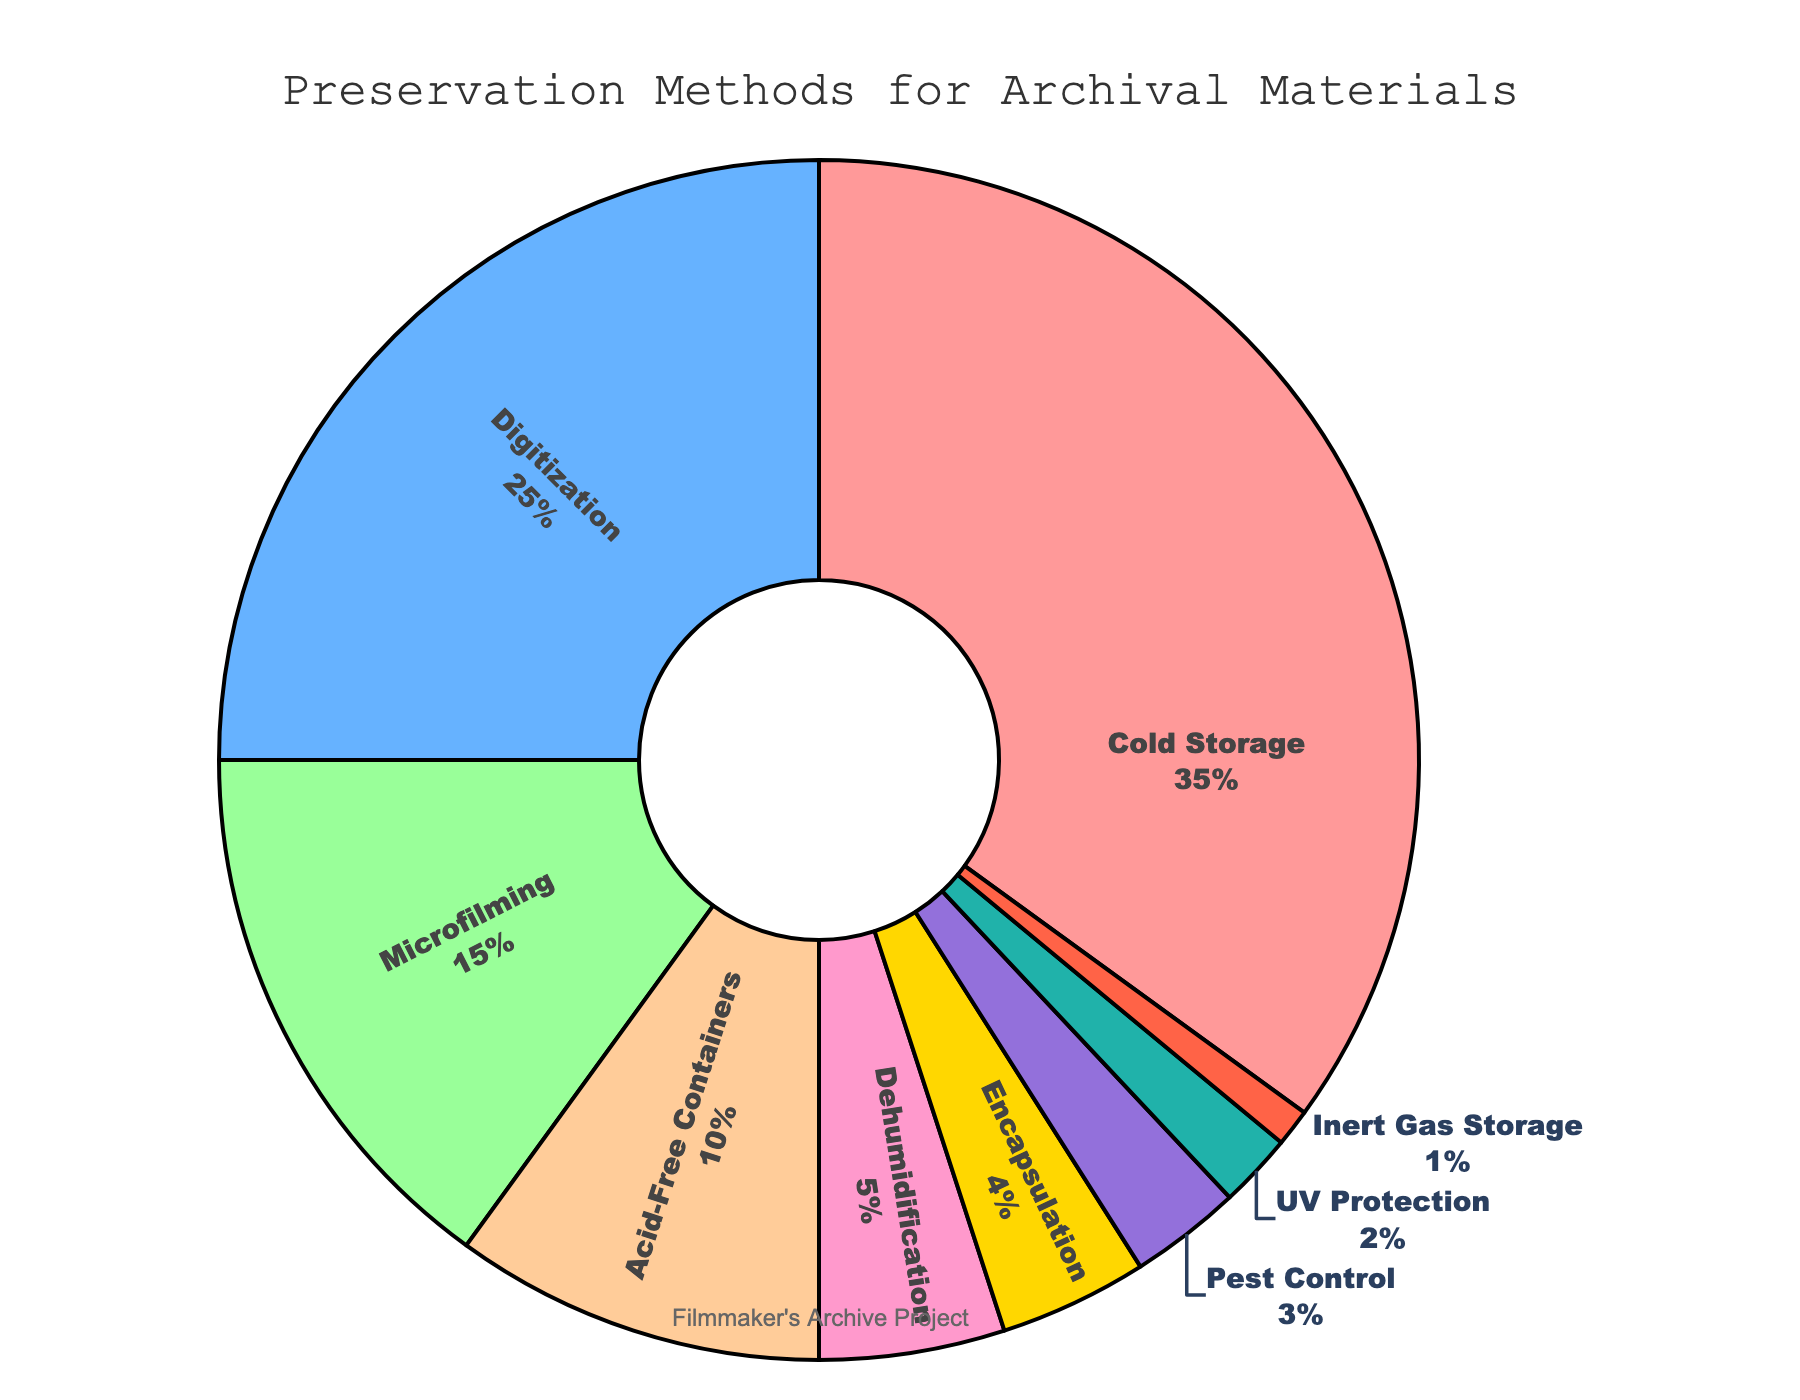What's the most commonly used preservation method? The largest segment on the pie chart corresponds to Cold Storage with 35%.
Answer: Cold Storage Which preservation method is used less frequently, Dehumidification or Encapsulation? Dehumidification is 5%, while Encapsulation is 4%. Since 5% is greater than 4%, Dehumidification is used more frequently than Encapsulation.
Answer: Encapsulation How much more prevalent is Digitization compared to Microfilming? Digitization accounts for 25% and Microfilming accounts for 15%. To find how much more prevalent, subtract 15 from 25: 25% - 15% = 10%
Answer: 10% List the preservation methods that collectively make up more than 70% of the collection. Cold Storage (35%), Digitization (25%), and Microfilming (15%) together make up 35% + 25% + 15% = 75%, which is more than 70%.
Answer: Cold Storage, Digitization, Microfilming What is the combined percentage of Acid-Free Containers, Dehumidification, and Encapsulation? The percentages are Acid-Free Containers (10%), Dehumidification (5%), and Encapsulation (4%). Add these: 10% + 5% + 4% = 19%
Answer: 19% What is the percentage difference between Pest Control and UV Protection? Pest Control accounts for 3%, and UV Protection accounts for 2%. The difference is 3% - 2% = 1%
Answer: 1% Which methods combined cover less than 10% of the collection? UV Protection (2%), Inert Gas Storage (1%), Pest Control (3%), and Encapsulation (4%) together make 2% + 1% + 3% + 4% = 10%. Methods below 10% are individually UV Protection, Pest Control, and Inert Gas Storage.
Answer: UV Protection, Inert Gas Storage, Pest Control Identify the preservation method with the second smallest percentage. Inert Gas Storage is the smallest with 1%. The second smallest is UV Protection with 2%.
Answer: UV Protection If a new preservation method is added with a percentage equal to that of Dehumidification, how much would that change the sum of Dehumidification and this new method? Dehumidification is 5%. Adding another method with the same percentage, it would become 5% + 5% = 10%.
Answer: 10% 